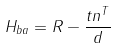<formula> <loc_0><loc_0><loc_500><loc_500>H _ { b a } = R - \frac { t n ^ { T } } { d }</formula> 